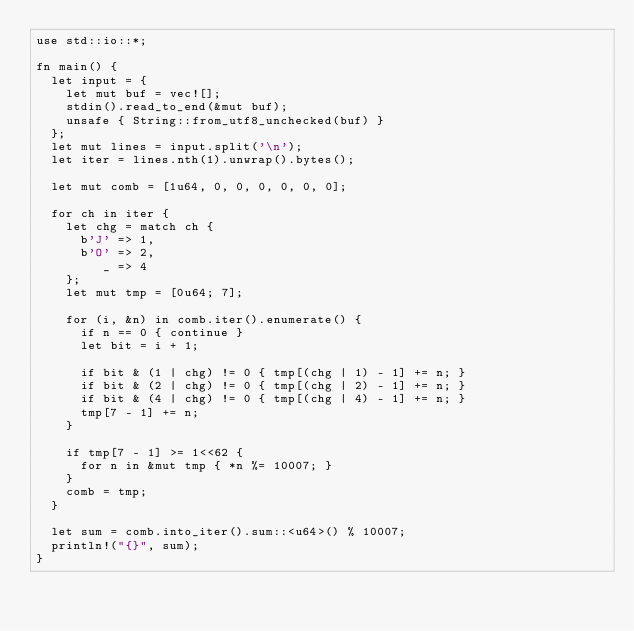Convert code to text. <code><loc_0><loc_0><loc_500><loc_500><_Rust_>use std::io::*;

fn main() {
  let input = {
    let mut buf = vec![];
    stdin().read_to_end(&mut buf);
    unsafe { String::from_utf8_unchecked(buf) }
  };
  let mut lines = input.split('\n');
  let iter = lines.nth(1).unwrap().bytes();

  let mut comb = [1u64, 0, 0, 0, 0, 0, 0];

  for ch in iter {
    let chg = match ch {
      b'J' => 1,
      b'O' => 2,
         _ => 4
    };
    let mut tmp = [0u64; 7];

    for (i, &n) in comb.iter().enumerate() {
      if n == 0 { continue }
      let bit = i + 1;

      if bit & (1 | chg) != 0 { tmp[(chg | 1) - 1] += n; }
      if bit & (2 | chg) != 0 { tmp[(chg | 2) - 1] += n; }
      if bit & (4 | chg) != 0 { tmp[(chg | 4) - 1] += n; }
      tmp[7 - 1] += n;
    }

    if tmp[7 - 1] >= 1<<62 {
      for n in &mut tmp { *n %= 10007; }
    }
    comb = tmp;
  }

  let sum = comb.into_iter().sum::<u64>() % 10007;
  println!("{}", sum);
}

</code> 